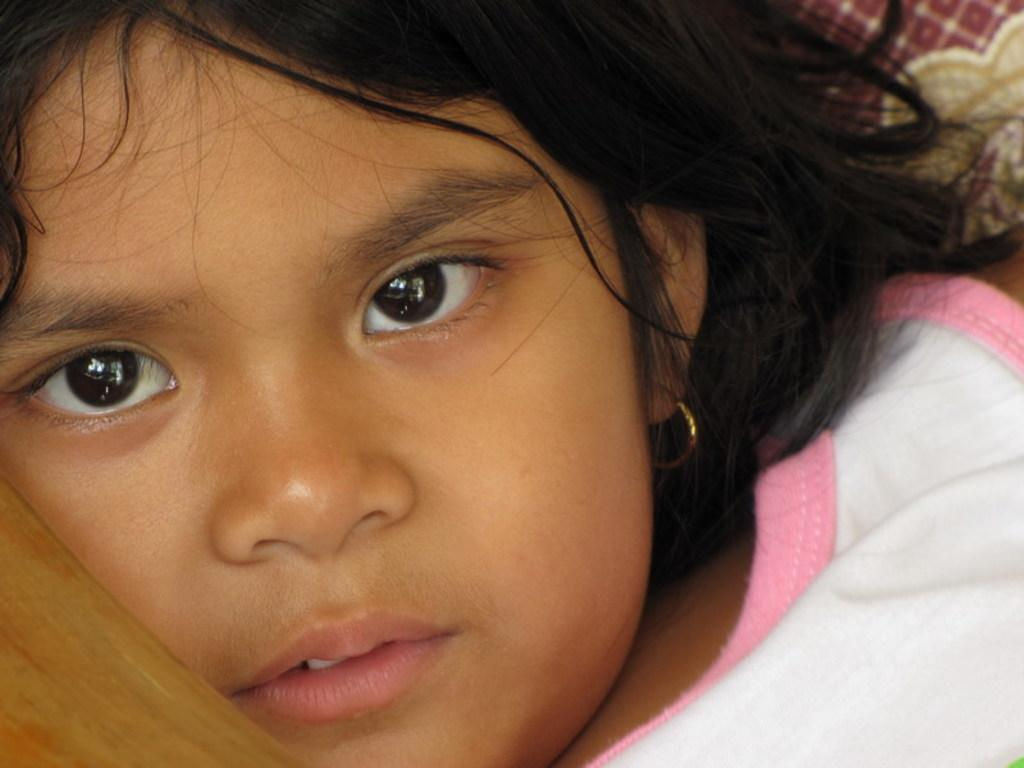Who is the main subject in the picture? There is a girl in the picture. What is the girl wearing on her upper body? The girl is wearing a white top. Are there any accessories visible on the girl? Yes, the girl is wearing an earring. What type of wing is visible on the girl in the image? There is no wing visible on the girl in the image. How many drops of water can be seen falling on the girl's earring? There are no drops of water present in the image. 